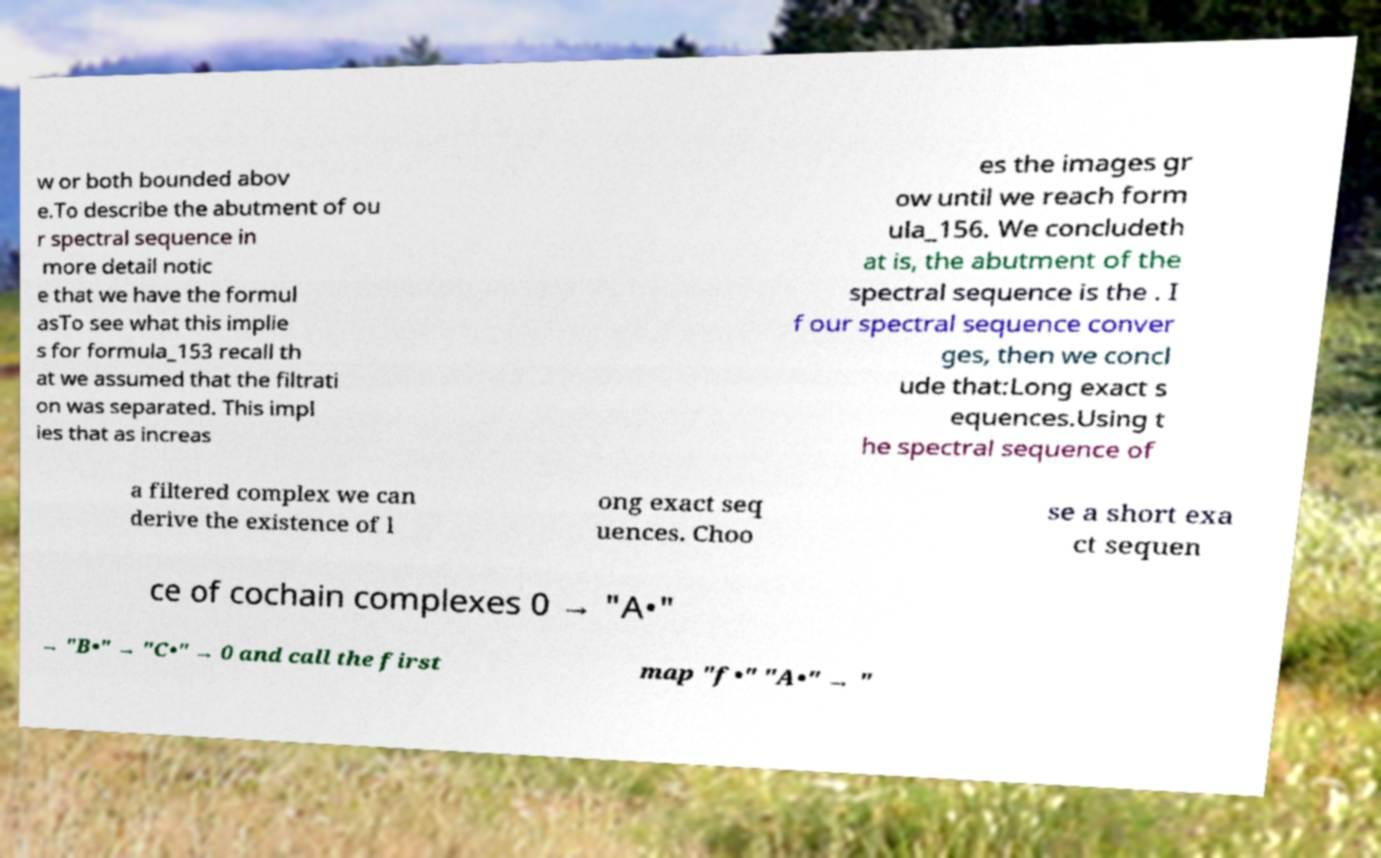Please identify and transcribe the text found in this image. w or both bounded abov e.To describe the abutment of ou r spectral sequence in more detail notic e that we have the formul asTo see what this implie s for formula_153 recall th at we assumed that the filtrati on was separated. This impl ies that as increas es the images gr ow until we reach form ula_156. We concludeth at is, the abutment of the spectral sequence is the . I f our spectral sequence conver ges, then we concl ude that:Long exact s equences.Using t he spectral sequence of a filtered complex we can derive the existence of l ong exact seq uences. Choo se a short exa ct sequen ce of cochain complexes 0 → "A•" → "B•" → "C•" → 0 and call the first map "f•" "A•" → " 